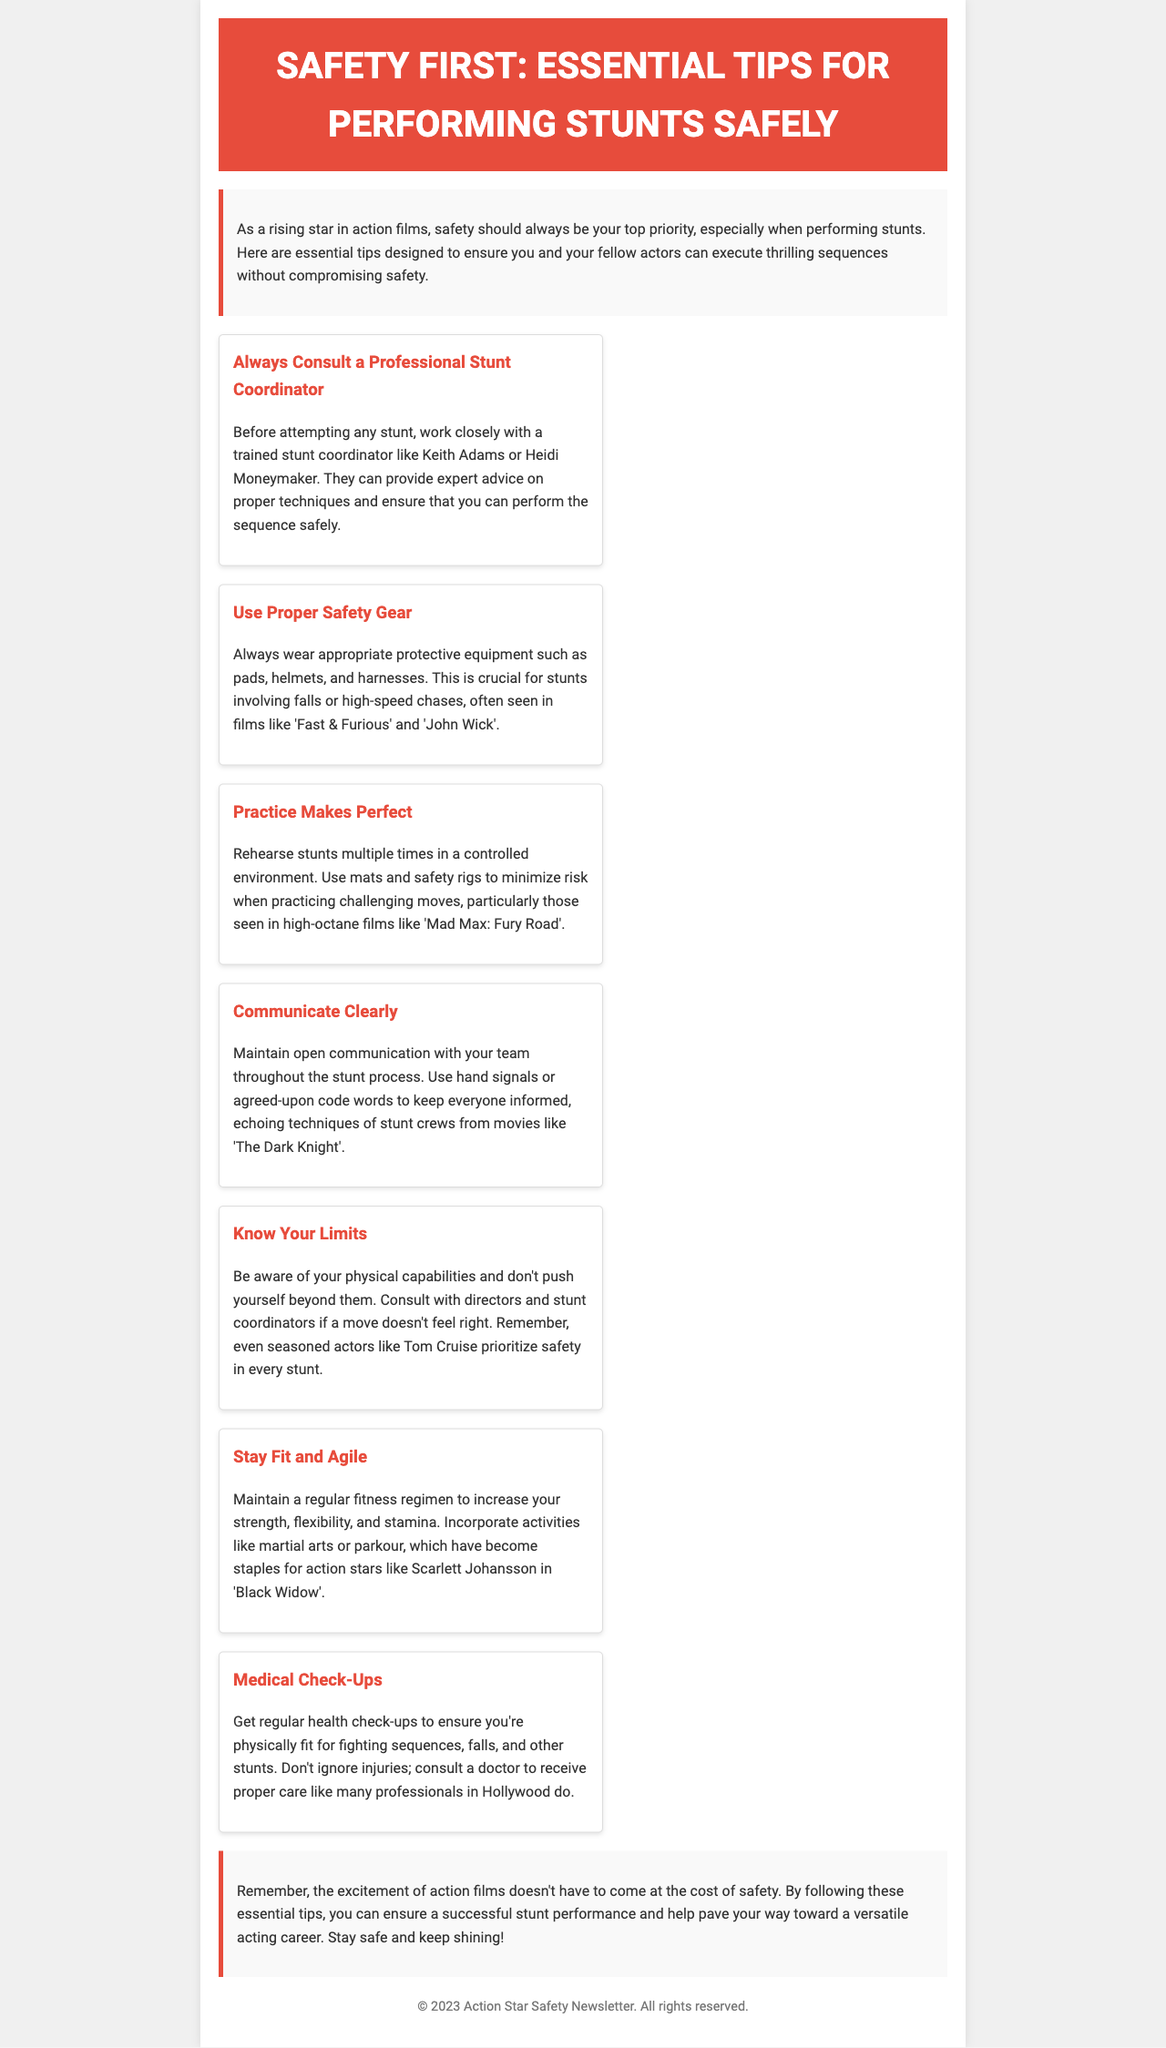what is the title of the newsletter? The title is prominently displayed at the top of the document, indicating the main focus of the content.
Answer: Safety First: Essential Tips for Performing Stunts Safely who are two examples of trained stunt coordinators mentioned? The document provides examples of professionals in the field of stunt coordination to emphasize the importance of consultation before performing stunts.
Answer: Keith Adams, Heidi Moneymaker name one type of protective equipment suggested for stunts. The document lists various types of safety gear necessary for reducing injury risk during stunts, highlighting their importance.
Answer: Pads what is one activity recommended to maintain fitness? The newsletter emphasizes the importance of physical fitness for performing stunts safely and suggests including specific activities to enhance agility and strength.
Answer: Martial arts how should communication be maintained during stunt processes? The document mentions specific methods to ensure clear communication among team members during stunts, critical for safety and coordination.
Answer: Hand signals what is highlighted as essential before attempting stunts? The newsletter instructs on the fundamental steps to take to ensure safety and preparedness prior to performing stunts.
Answer: Consult a Professional Stunt Coordinator what is one advised action if a stunt doesn't feel right? The document advises on proper procedures to follow when a performer feels uncomfortable or uncertain about executing a stunt.
Answer: Consult with directors and stunt coordinators 